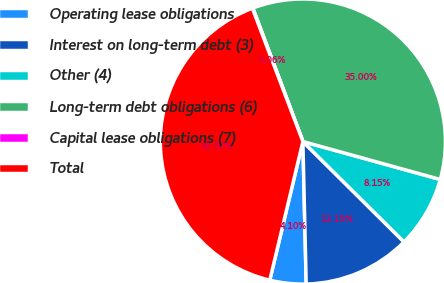Convert chart. <chart><loc_0><loc_0><loc_500><loc_500><pie_chart><fcel>Operating lease obligations<fcel>Interest on long-term debt (3)<fcel>Other (4)<fcel>Long-term debt obligations (6)<fcel>Capital lease obligations (7)<fcel>Total<nl><fcel>4.1%<fcel>12.19%<fcel>8.15%<fcel>35.0%<fcel>0.06%<fcel>40.5%<nl></chart> 